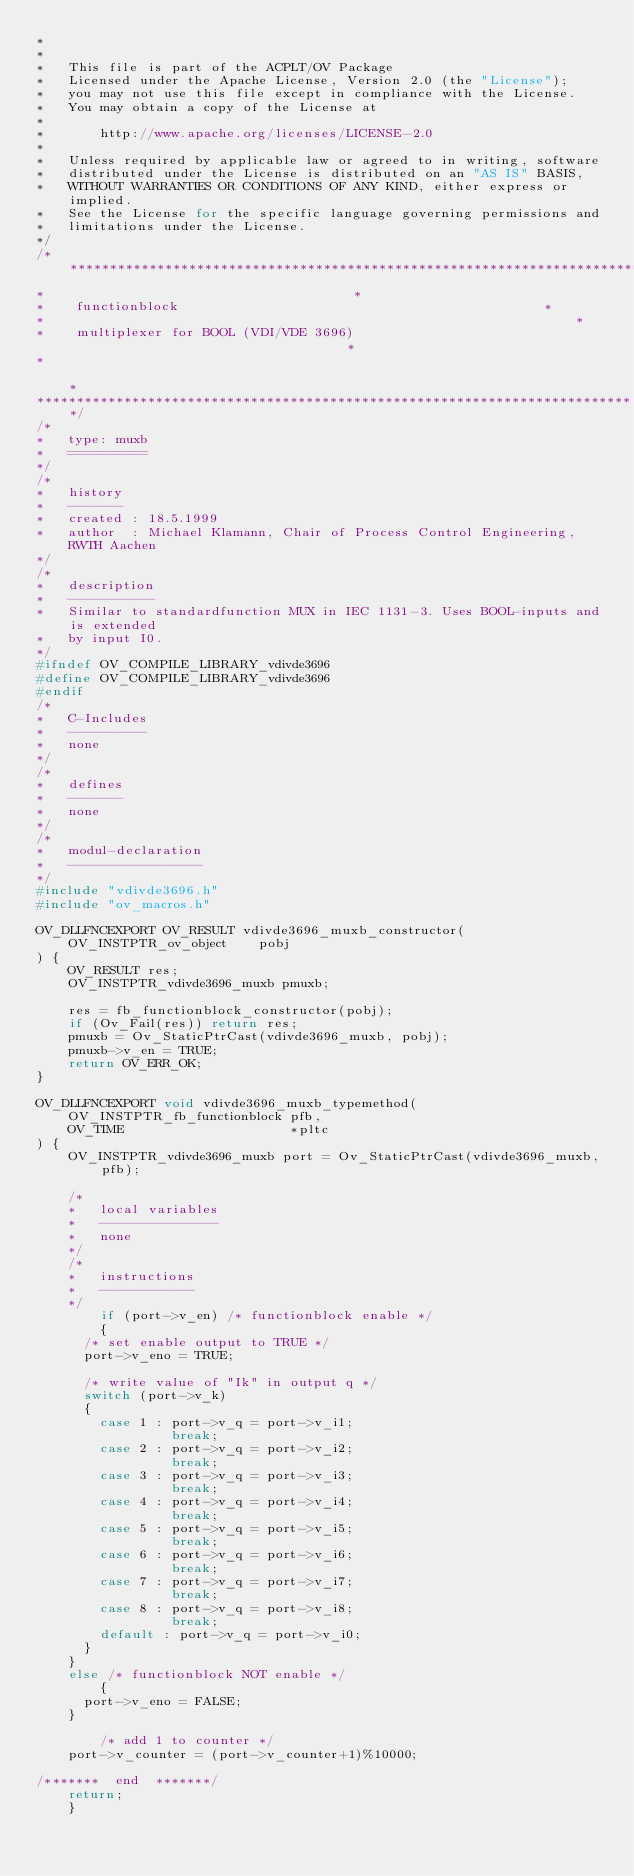<code> <loc_0><loc_0><loc_500><loc_500><_C_>*
*
*   This file is part of the ACPLT/OV Package 
*   Licensed under the Apache License, Version 2.0 (the "License");
*   you may not use this file except in compliance with the License.
*   You may obtain a copy of the License at
*
*       http://www.apache.org/licenses/LICENSE-2.0
*
*   Unless required by applicable law or agreed to in writing, software
*   distributed under the License is distributed on an "AS IS" BASIS,
*   WITHOUT WARRANTIES OR CONDITIONS OF ANY KIND, either express or implied.
*   See the License for the specific language governing permissions and
*   limitations under the License.
*/
/****************************************************************************
*									    *
*    functionblock                              			    *
*                                                       		    *
*    multiplexer for BOOL (VDI/VDE 3696)                                    *
*                                                                           *
****************************************************************************/
/*
*   type: muxb
*   ==========
*/
/*
*   history
*   -------
*   created : 18.5.1999
*   author  : Michael Klamann, Chair of Process Control Engineering, RWTH Aachen
*/
/*
*   description
*   -----------
*   Similar to standardfunction MUX in IEC 1131-3. Uses BOOL-inputs and is extended
*   by input I0.
*/
#ifndef OV_COMPILE_LIBRARY_vdivde3696
#define OV_COMPILE_LIBRARY_vdivde3696
#endif
/*
*   C-Includes
*   ----------
*   none
*/
/*  
*   defines
*   -------
*   none
*/
/*
*   modul-declaration
*   -----------------
*/
#include "vdivde3696.h"
#include "ov_macros.h"

OV_DLLFNCEXPORT OV_RESULT vdivde3696_muxb_constructor(
	OV_INSTPTR_ov_object	pobj
) {
	OV_RESULT res;
	OV_INSTPTR_vdivde3696_muxb pmuxb;

	res = fb_functionblock_constructor(pobj);
	if (Ov_Fail(res)) return res;
	pmuxb = Ov_StaticPtrCast(vdivde3696_muxb, pobj);
	pmuxb->v_en = TRUE;
	return OV_ERR_OK;
}

OV_DLLFNCEXPORT void vdivde3696_muxb_typemethod(
	OV_INSTPTR_fb_functionblock	pfb,
	OV_TIME						*pltc
) {
	OV_INSTPTR_vdivde3696_muxb port = Ov_StaticPtrCast(vdivde3696_muxb, pfb);

	/*
	*   local variables
	*   ---------------
	*   none
	*/
	/*
	*   instructions
	*   ------------
	*/
        if (port->v_en) /* functionblock enable */
        {
	  /* set enable output to TRUE */
	  port->v_eno = TRUE;

	  /* write value of "Ik" in output q */
	  switch (port->v_k)
	  {
	    case 1 : port->v_q = port->v_i1;
	             break;
	    case 2 : port->v_q = port->v_i2;
	             break;
	    case 3 : port->v_q = port->v_i3;
	             break;
	    case 4 : port->v_q = port->v_i4;
	             break;
	    case 5 : port->v_q = port->v_i5;
	             break;
	    case 6 : port->v_q = port->v_i6;
	             break;
	    case 7 : port->v_q = port->v_i7;
	             break;
	    case 8 : port->v_q = port->v_i8;
	             break;
	    default : port->v_q = port->v_i0;
	  }
 	}
	else /* functionblock NOT enable */
        {
	  port->v_eno = FALSE;
	}

        /* add 1 to counter */
	port->v_counter = (port->v_counter+1)%10000;

/*******  end  *******/
	return;
	}










</code> 